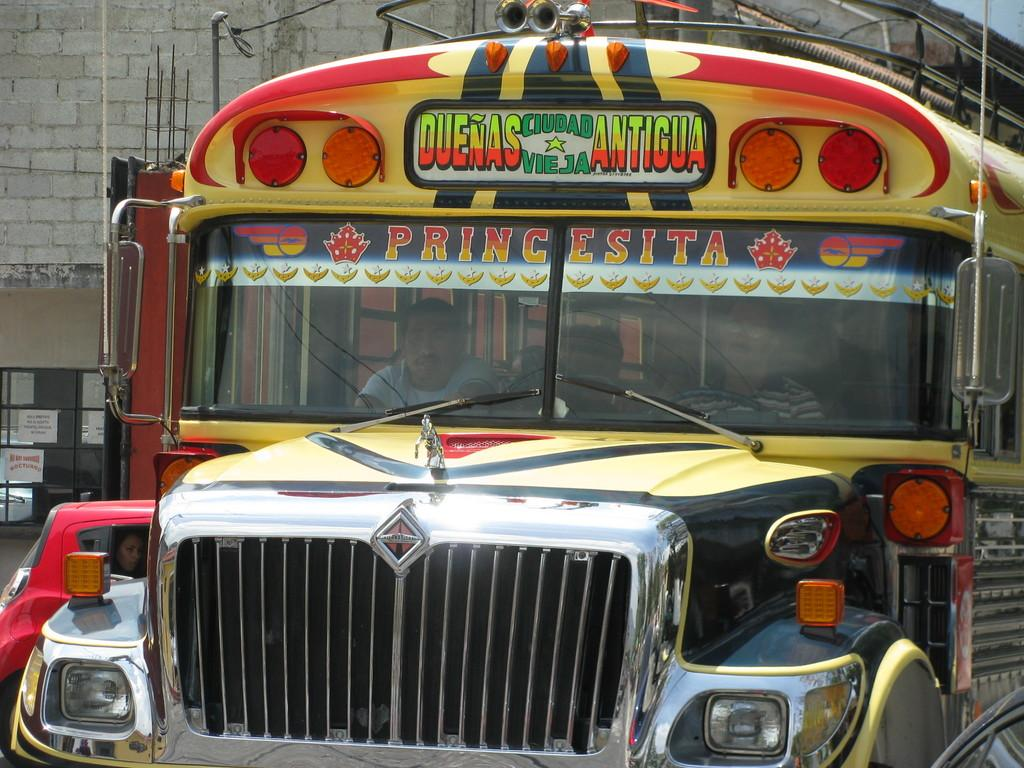What mode of transportation are the people in the image using? The people are in a bus. What can be seen on the left side of the image? There is a car and a building on the left side of the image. How many chairs are visible in the image? There are no chairs visible in the image; it features a bus with people inside and objects on the left side of the image. What type of bait is being used by the people in the image? There is no bait present in the image; it features a bus with people inside and objects on the left side of the image. 